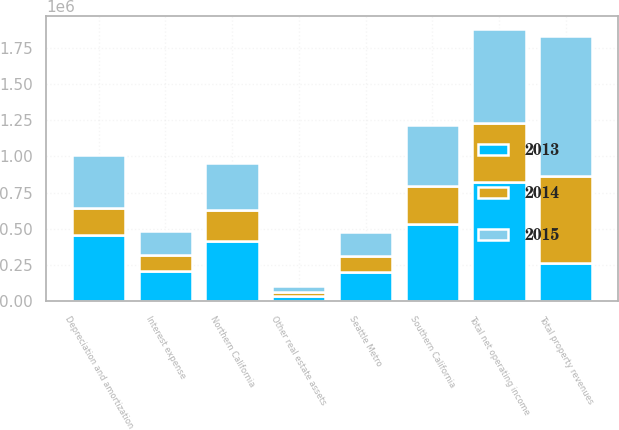Convert chart to OTSL. <chart><loc_0><loc_0><loc_500><loc_500><stacked_bar_chart><ecel><fcel>Southern California<fcel>Northern California<fcel>Seattle Metro<fcel>Other real estate assets<fcel>Total property revenues<fcel>Total net operating income<fcel>Depreciation and amortization<fcel>Interest expense<nl><fcel>2013<fcel>529440<fcel>416347<fcel>201418<fcel>38293<fcel>263582<fcel>821990<fcel>453423<fcel>204827<nl><fcel>2015<fcel>423570<fcel>326996<fcel>168337<fcel>42688<fcel>961591<fcel>649045<fcel>360592<fcel>164551<nl><fcel>2014<fcel>263582<fcel>210831<fcel>107796<fcel>21118<fcel>603327<fcel>405991<fcel>192420<fcel>116524<nl></chart> 